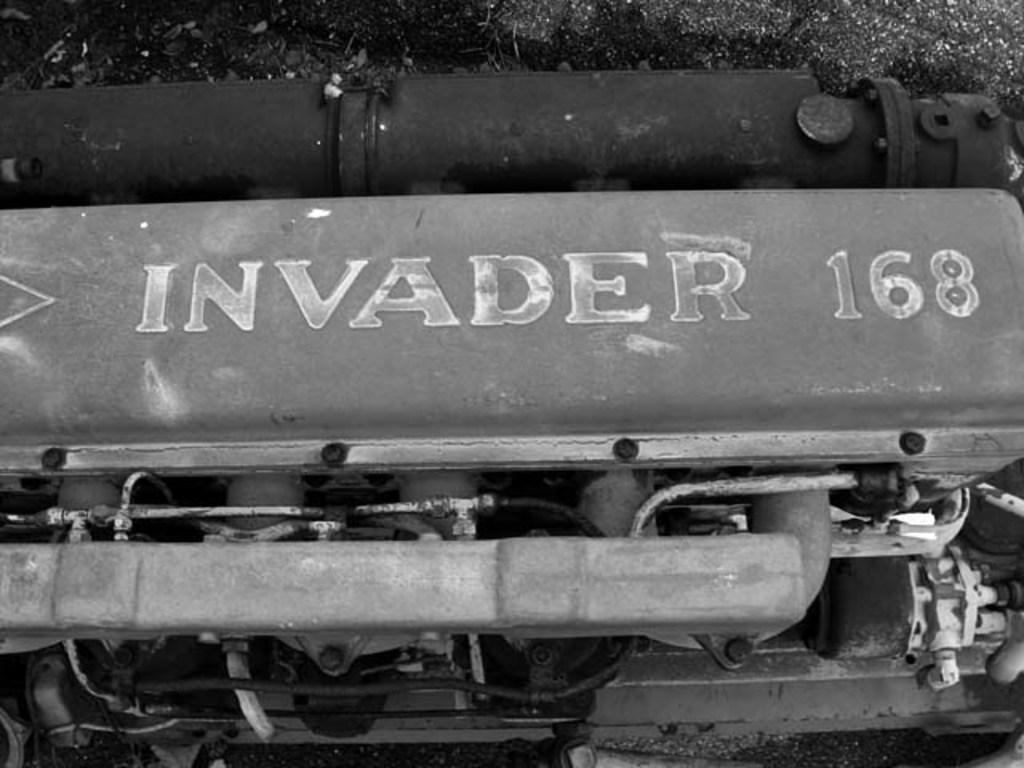<image>
Offer a succinct explanation of the picture presented. A large engine is marked as Invader 168. 